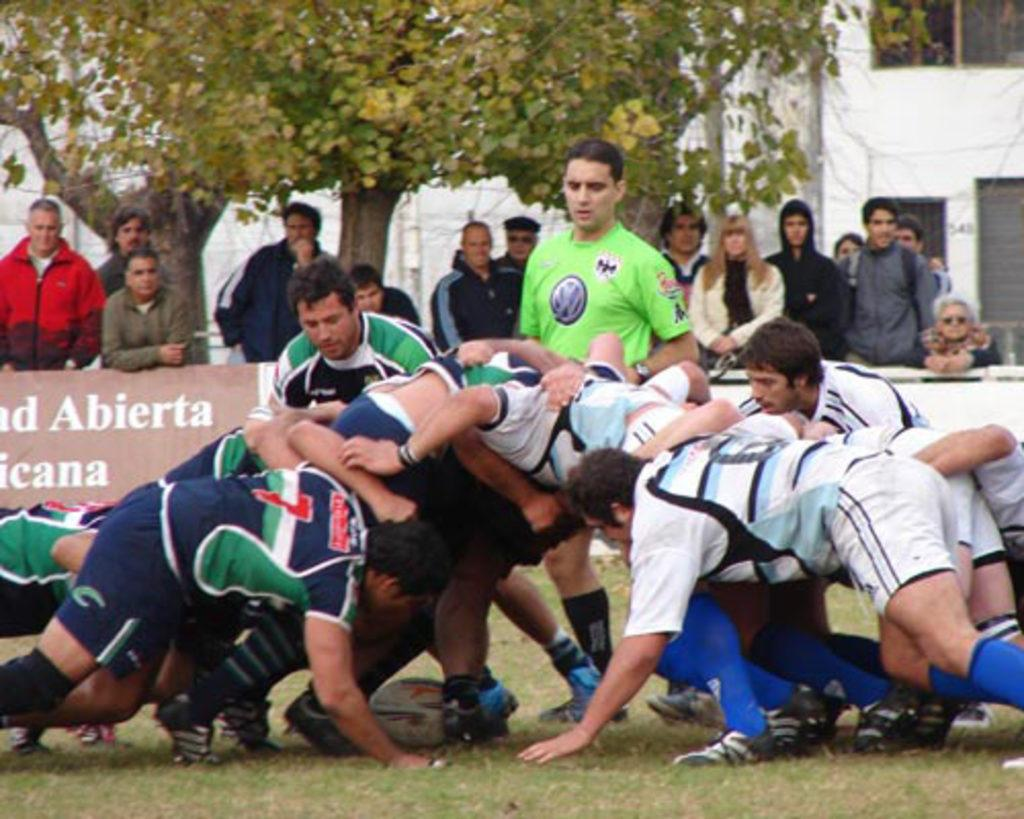What sport are the people playing in the image? The people are playing American football in the image. What is the surface they are playing on? There is green grass at the bottom of the image. What can be seen in the background of the image? There is a building and a tree in the background of the image. What type of skirt is the goose wearing in the image? There is no goose or skirt present in the image. 